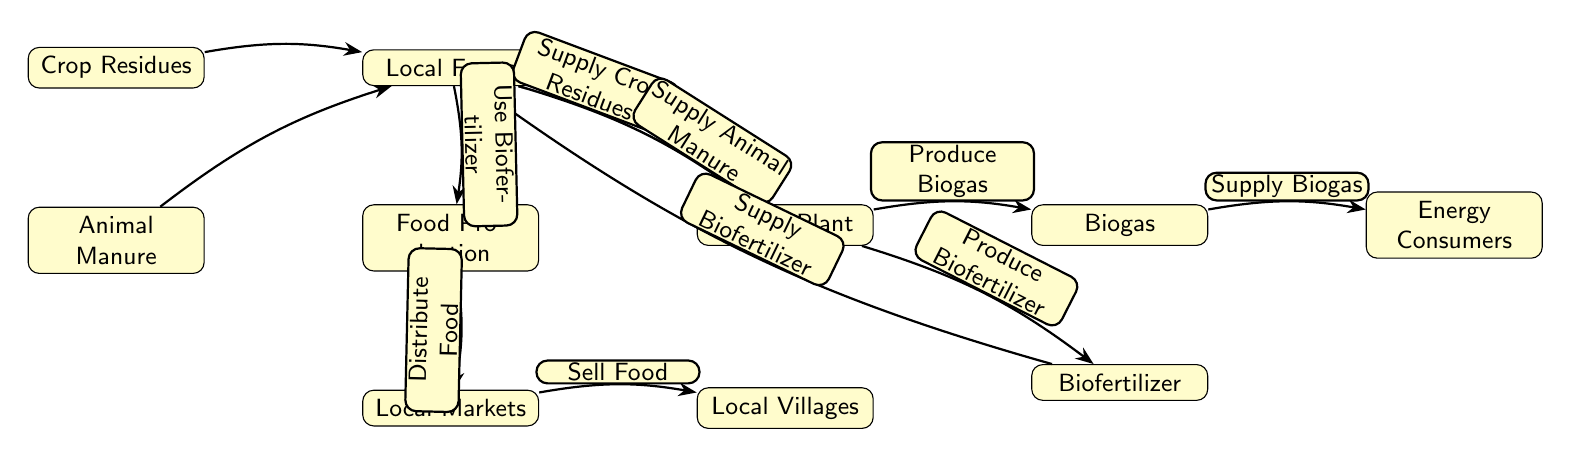What is the primary input to the Biogas Plant? The diagram shows that the Biogas Plant receives inputs from two sources: Crop Residues and Animal Manure. These are the primary materials supplied by Local Farms to the Biogas Plant.
Answer: Crop Residues and Animal Manure How many nodes are present in the diagram? By counting each labeled node in the diagram, we can see there are a total of eight distinct nodes: Biogas Plant, Local Farms, Crop Residues, Animal Manure, Biogas, Biofertilizer, Energy Consumers, Food Production, Local Markets, and Local Villages. In total, there are ten nodes.
Answer: Ten What is produced by the Biogas Plant? The diagram illustrates that the Biogas Plant produces two distinct outputs: Biogas and Biofertilizer. These are shown as directed outputs from the Biogas Plant node.
Answer: Biogas and Biofertilizer What do local farms receive from the Biogas Plant? According to the diagram, Local Farms receive Biofertilizer from the Biogas Plant. This output is directed towards Local Farms, indicating its use in agricultural production.
Answer: Biofertilizer How does Food Production connect with Local Markets? The diagram shows a direct connection from Food Production to Local Markets, indicating that food produced is distributed and would subsequently be sold in these markets.
Answer: Distribute Food What is the role of Energy Consumers in this food chain? Energy Consumers receive Biogas produced by the Biogas Plant. This indicates that Energy Consumers are part of the utilization of energy resources generated in the local production cycle.
Answer: Supply Biogas Which node indicates the selling of food? The Local Markets node represents the selling of food. According to the diagram, the connection from Local Markets leads to Local Villages, indicating food is sold there.
Answer: Local Markets Which input contributes to increased food production on Local Farms? The diagram indicates that Local Farms use Biofertilizer produced from the Biogas Plant. This connection highlights how the input enhances the food production process.
Answer: Use Biofertilizer How many connections lead into the Biogas Plant? The diagram shows that there are two incoming connections leading into the Biogas Plant: one from Crop Residues and another from Animal Manure, representing the inputs to the facility.
Answer: Two 